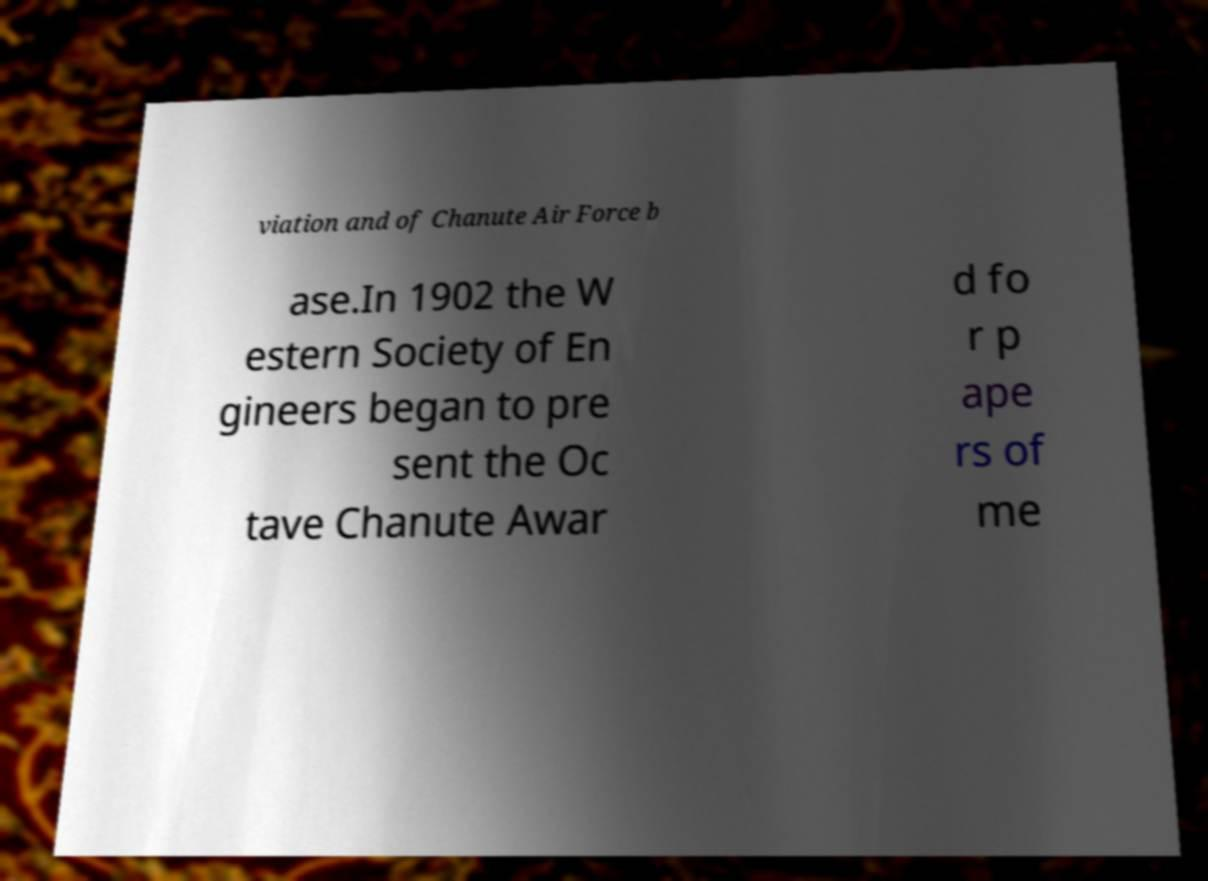Please identify and transcribe the text found in this image. viation and of Chanute Air Force b ase.In 1902 the W estern Society of En gineers began to pre sent the Oc tave Chanute Awar d fo r p ape rs of me 